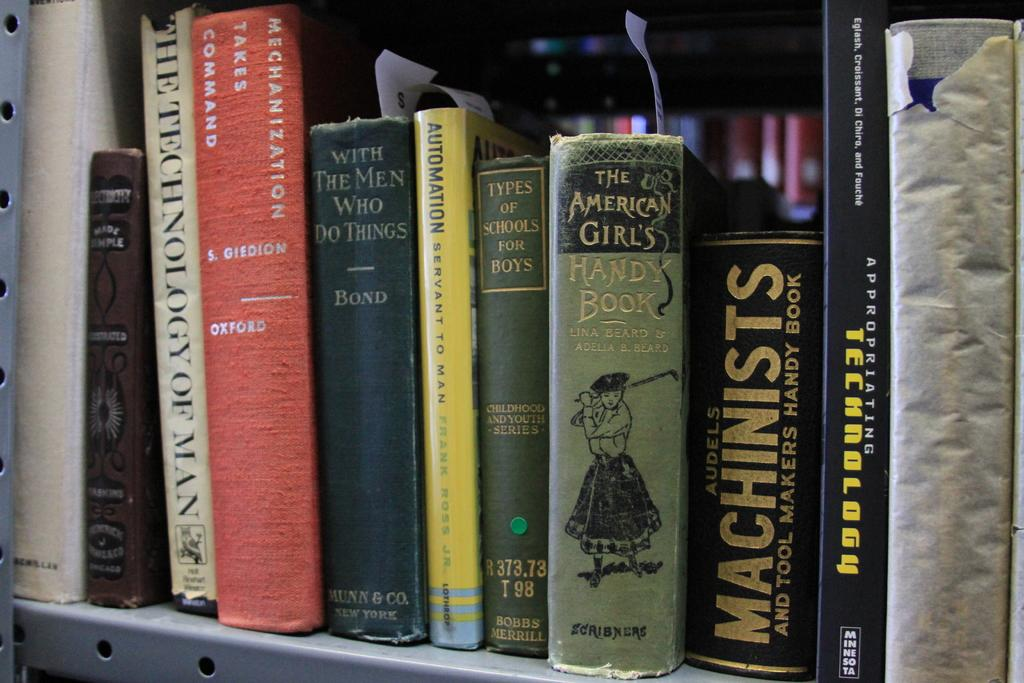<image>
Share a concise interpretation of the image provided. A shelf full of books with titles such as The American Girl's Handy Book and With the Men Who Do Things. 